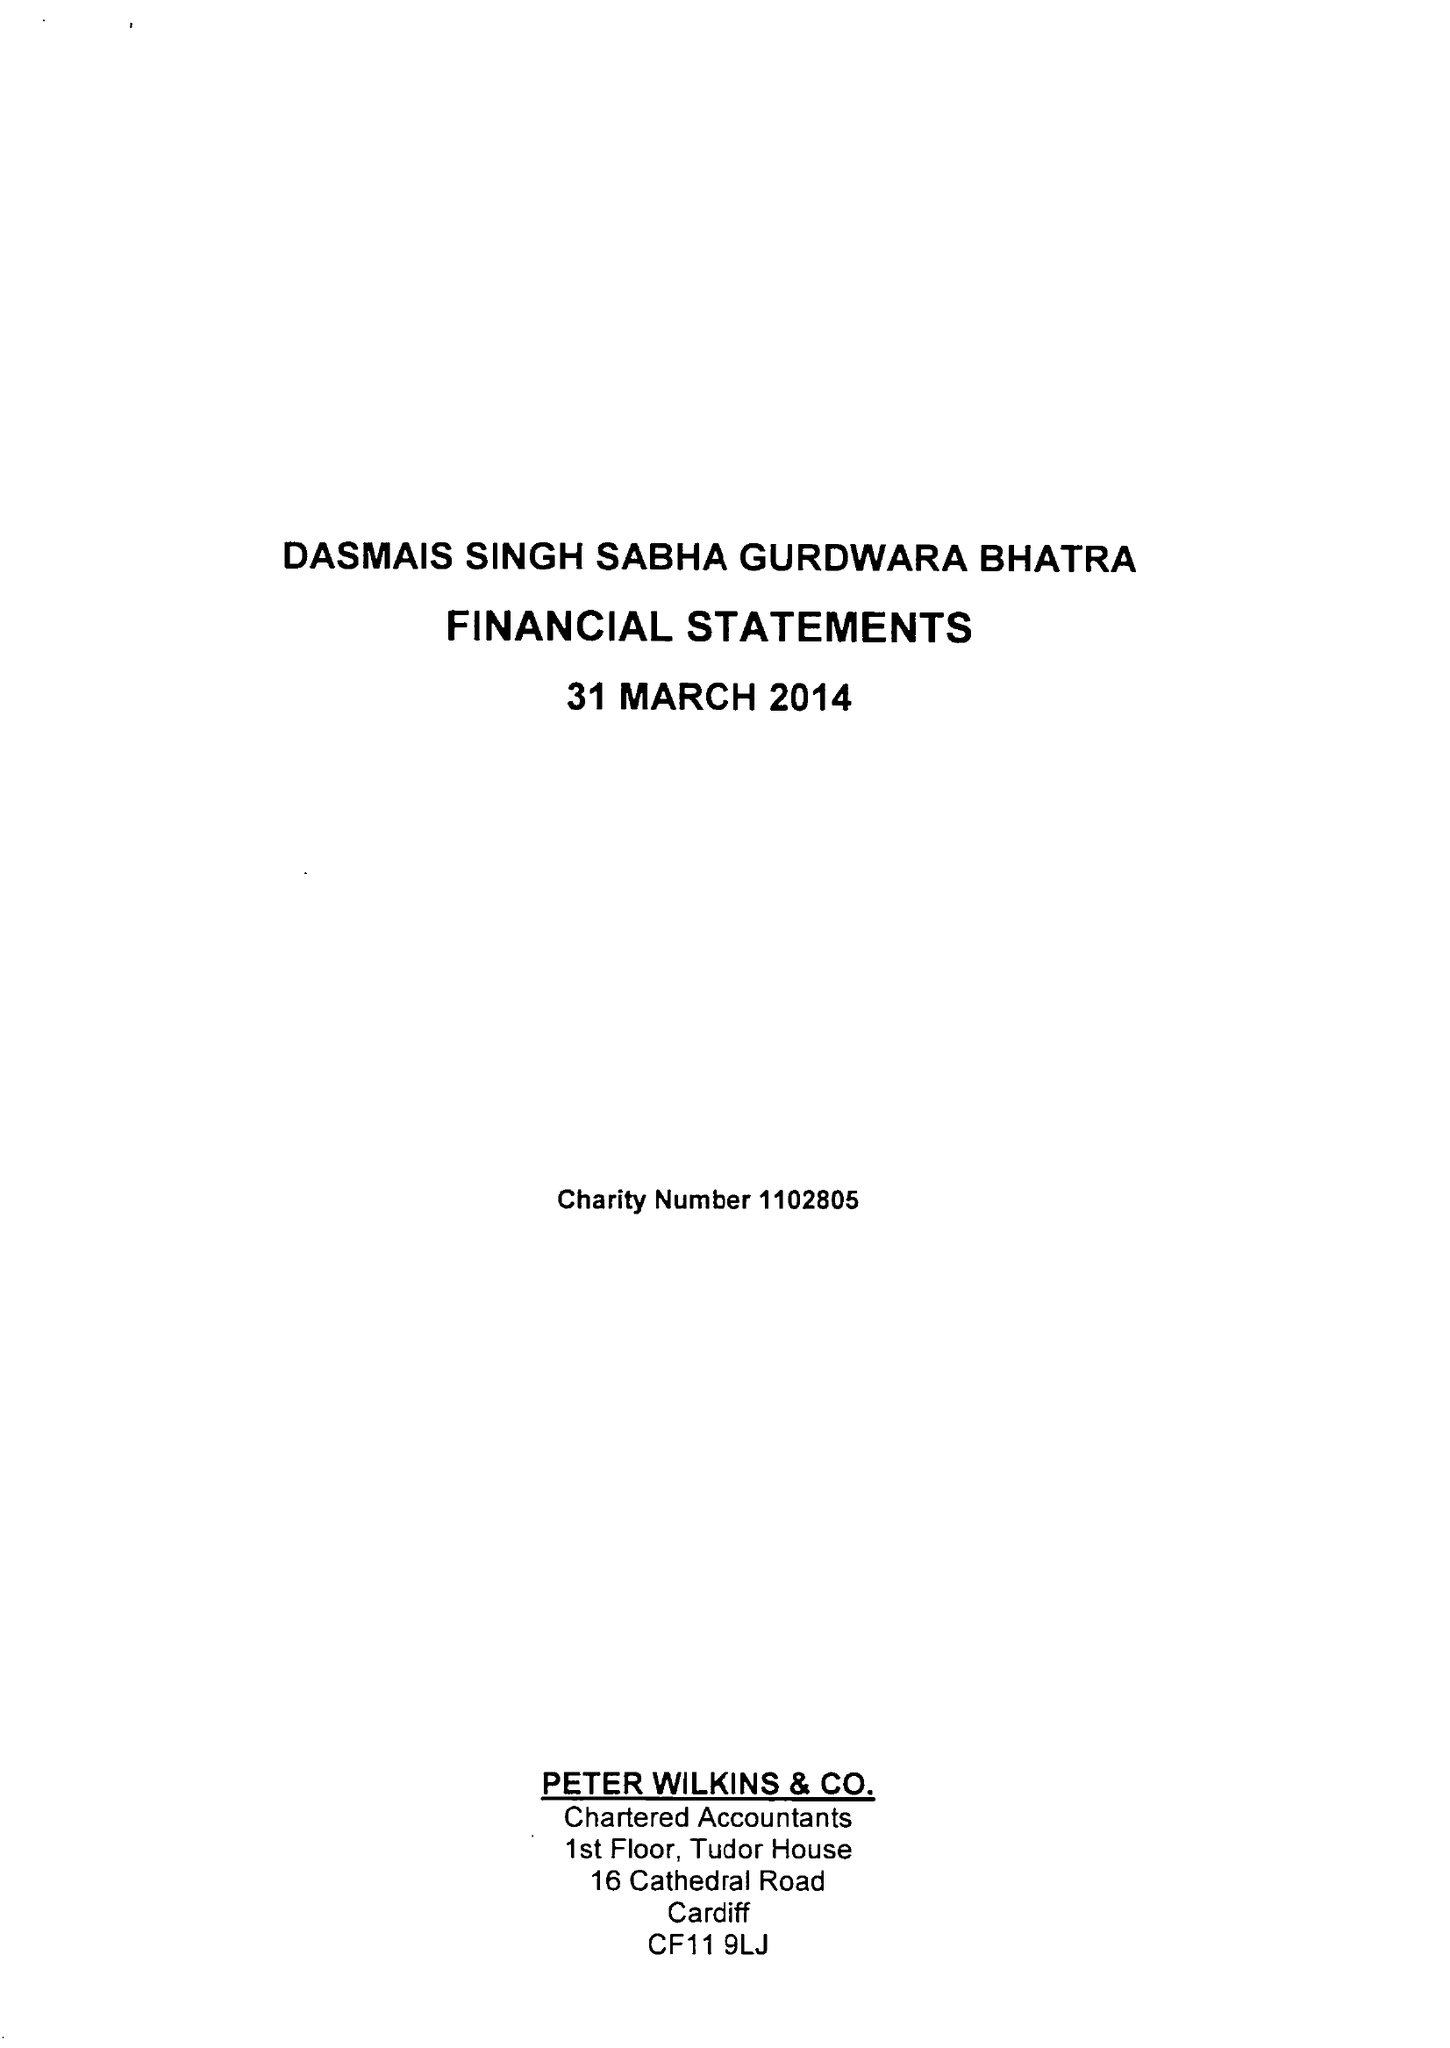What is the value for the income_annually_in_british_pounds?
Answer the question using a single word or phrase. 54590.00 